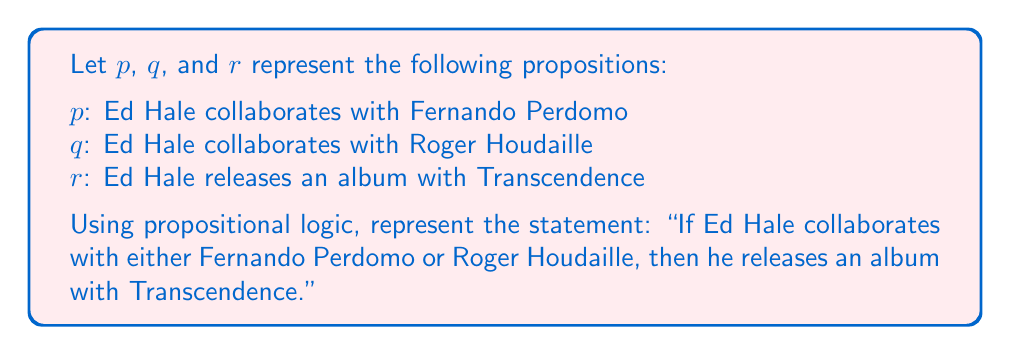Can you answer this question? To solve this problem, we need to break down the statement into its logical components and use the appropriate logical connectives. Let's approach this step-by-step:

1. The phrase "Ed Hale collaborates with either Fernando Perdomo or Roger Houdaille" can be represented as $(p \lor q)$, where $\lor$ is the logical OR operator.

2. The phrase "he releases an album with Transcendence" is simply represented by $r$.

3. The overall statement is an implication, where the first part implies the second. In propositional logic, we represent this with the symbol $\rightarrow$.

4. Putting it all together, we get:

   $$(p \lor q) \rightarrow r$$

This logical statement reads as: "If $p$ OR $q$ is true, then $r$ is true." In the context of Ed Hale's musical collaborations, it means that if he collaborates with either Fernando Perdomo or Roger Houdaille (or both), then he releases an album with Transcendence.

It's worth noting that this logical statement doesn't imply that collaborating with Fernando Perdomo or Roger Houdaille is the only way Ed Hale releases an album with Transcendence. It only states that if either of those collaborations occurs, an album with Transcendence follows.
Answer: $$(p \lor q) \rightarrow r$$ 